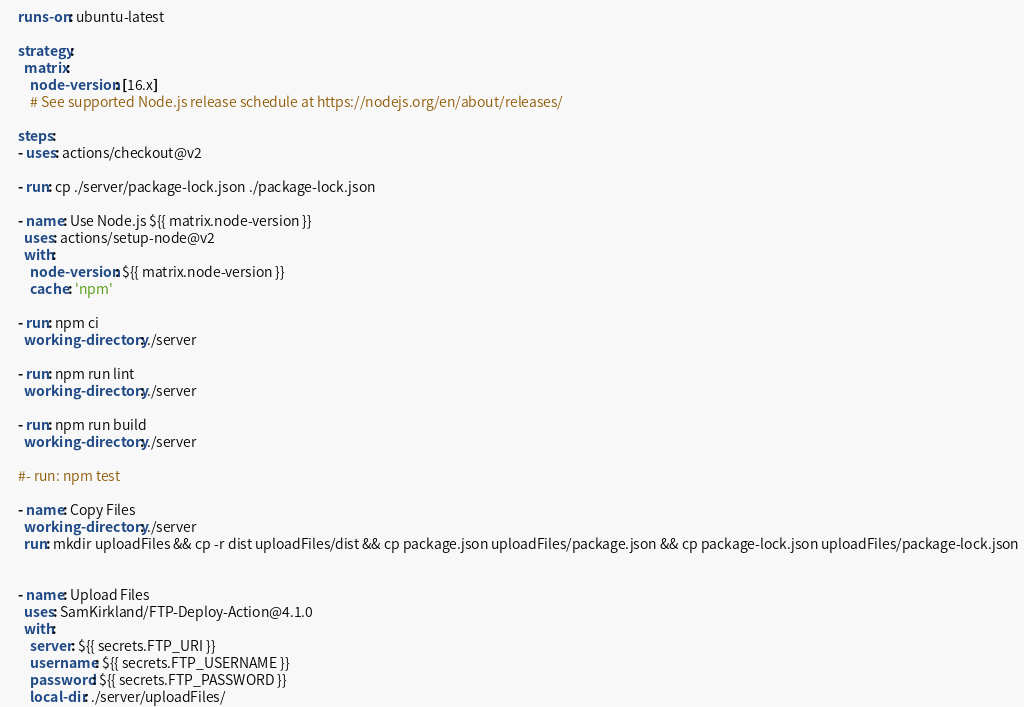Convert code to text. <code><loc_0><loc_0><loc_500><loc_500><_YAML_>    runs-on: ubuntu-latest

    strategy:
      matrix:
        node-version: [16.x]
        # See supported Node.js release schedule at https://nodejs.org/en/about/releases/

    steps:
    - uses: actions/checkout@v2

    - run: cp ./server/package-lock.json ./package-lock.json

    - name: Use Node.js ${{ matrix.node-version }}
      uses: actions/setup-node@v2
      with:
        node-version: ${{ matrix.node-version }}
        cache: 'npm'
    
    - run: npm ci
      working-directory: ./server
    
    - run: npm run lint
      working-directory: ./server
    
    - run: npm run build
      working-directory: ./server
    
    #- run: npm test
    
    - name: Copy Files
      working-directory: ./server
      run: mkdir uploadFiles && cp -r dist uploadFiles/dist && cp package.json uploadFiles/package.json && cp package-lock.json uploadFiles/package-lock.json
      
    
    - name: Upload Files
      uses: SamKirkland/FTP-Deploy-Action@4.1.0
      with:
        server: ${{ secrets.FTP_URI }}
        username: ${{ secrets.FTP_USERNAME }}
        password: ${{ secrets.FTP_PASSWORD }}
        local-dir: ./server/uploadFiles/
</code> 